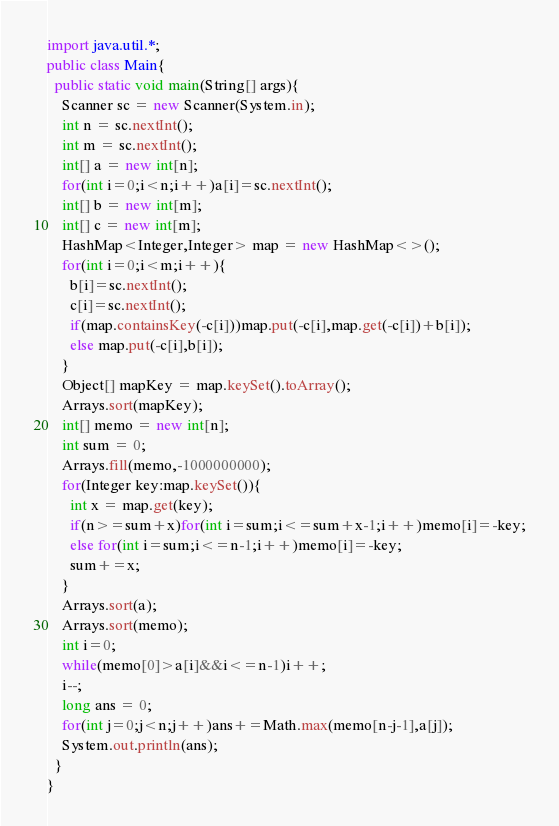Convert code to text. <code><loc_0><loc_0><loc_500><loc_500><_Java_>import java.util.*;
public class Main{
  public static void main(String[] args){
    Scanner sc = new Scanner(System.in);
    int n = sc.nextInt();
    int m = sc.nextInt();
    int[] a = new int[n];
    for(int i=0;i<n;i++)a[i]=sc.nextInt();
    int[] b = new int[m];
    int[] c = new int[m];
    HashMap<Integer,Integer> map = new HashMap<>();
    for(int i=0;i<m;i++){
      b[i]=sc.nextInt();
      c[i]=sc.nextInt();
      if(map.containsKey(-c[i]))map.put(-c[i],map.get(-c[i])+b[i]);
      else map.put(-c[i],b[i]);
    }
    Object[] mapKey = map.keySet().toArray();
    Arrays.sort(mapKey);
    int[] memo = new int[n];
    int sum = 0;
    Arrays.fill(memo,-1000000000);
    for(Integer key:map.keySet()){
      int x = map.get(key);
      if(n>=sum+x)for(int i=sum;i<=sum+x-1;i++)memo[i]=-key;
      else for(int i=sum;i<=n-1;i++)memo[i]=-key;
      sum+=x;
    }
    Arrays.sort(a);
    Arrays.sort(memo);
    int i=0;
    while(memo[0]>a[i]&&i<=n-1)i++;
    i--;
    long ans = 0;
    for(int j=0;j<n;j++)ans+=Math.max(memo[n-j-1],a[j]);
    System.out.println(ans);
  }
}</code> 